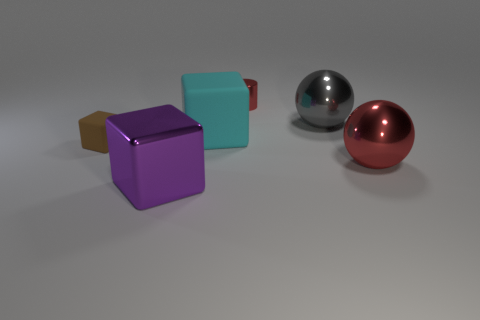How does the lighting in the scene affect the perception of the objects? The lighting creates subtle highlights and gentle shadows, enhancing the objects' three-dimensional form. It appears diffused, providing soft illumination without harsh contrasts, which can help us better understand the volume and textures of the objects. 